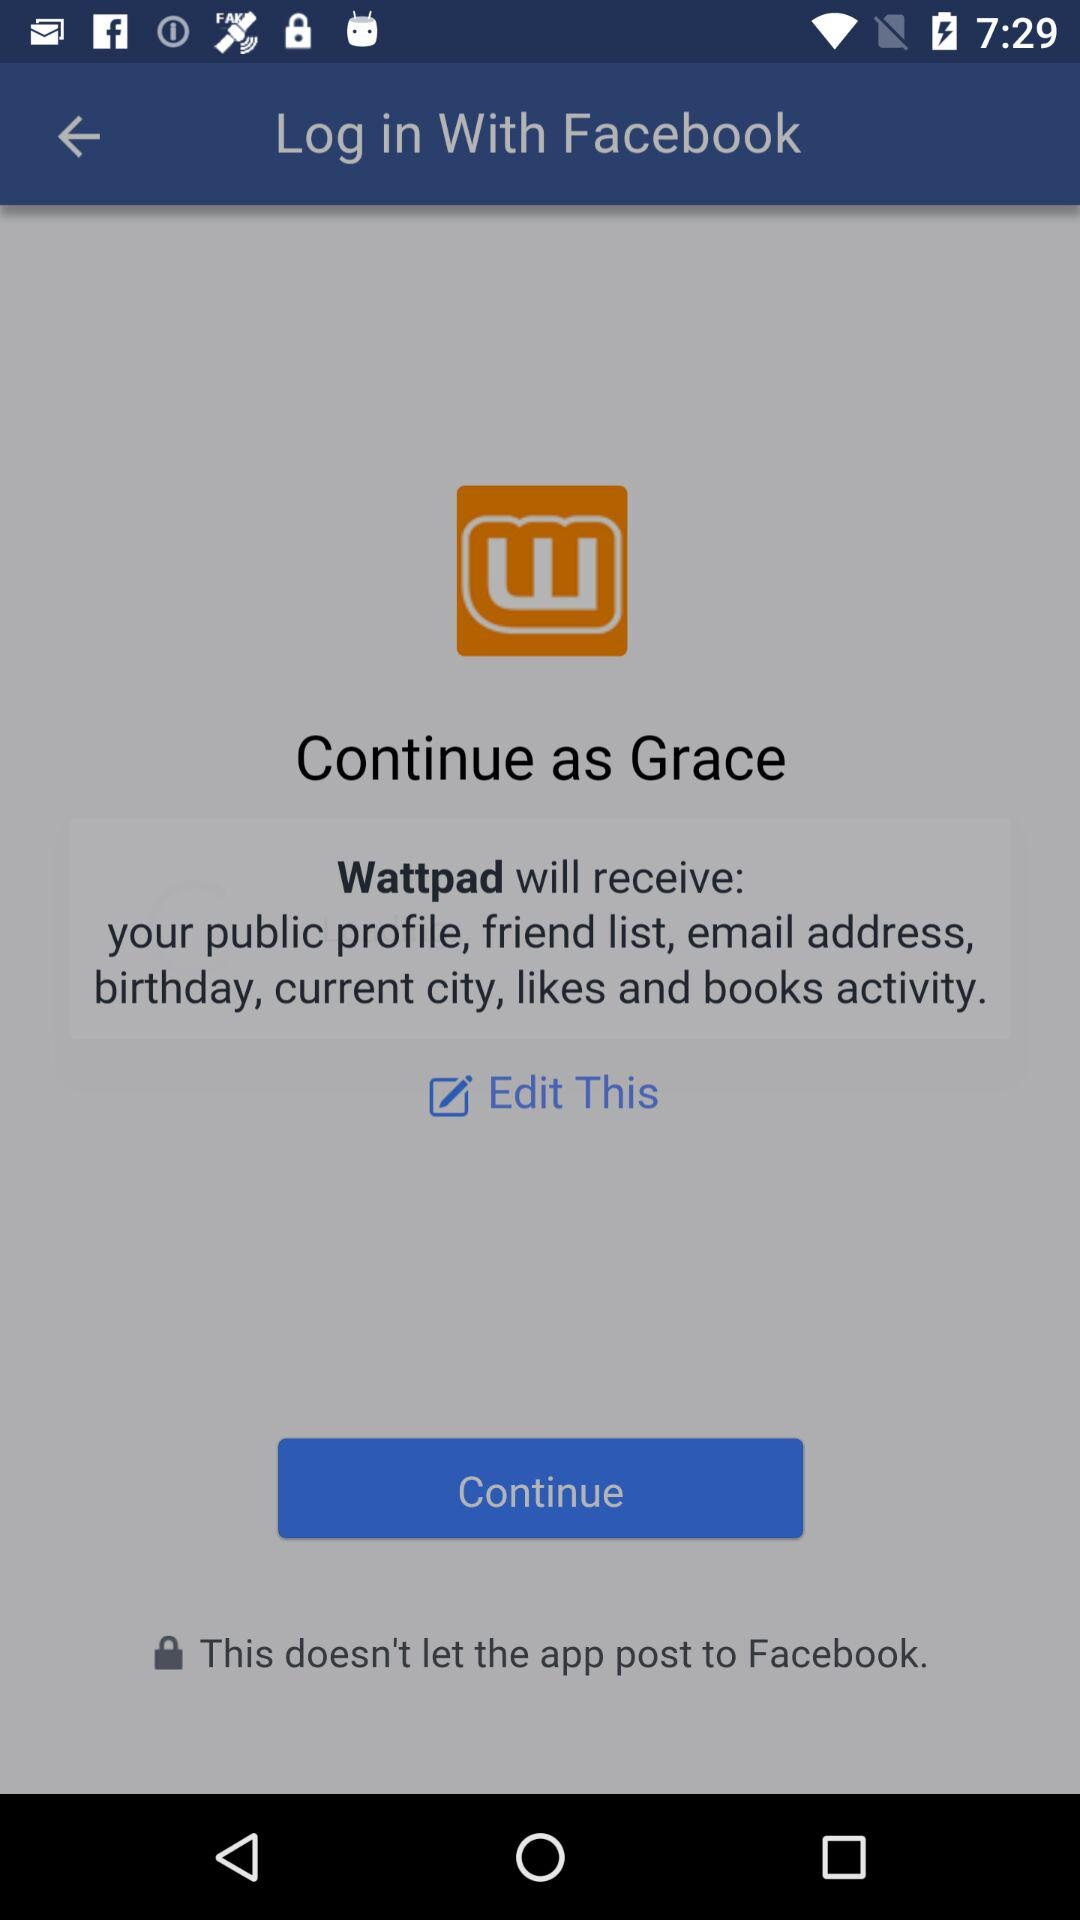What is the name of the user? The name of the user is Grace. 